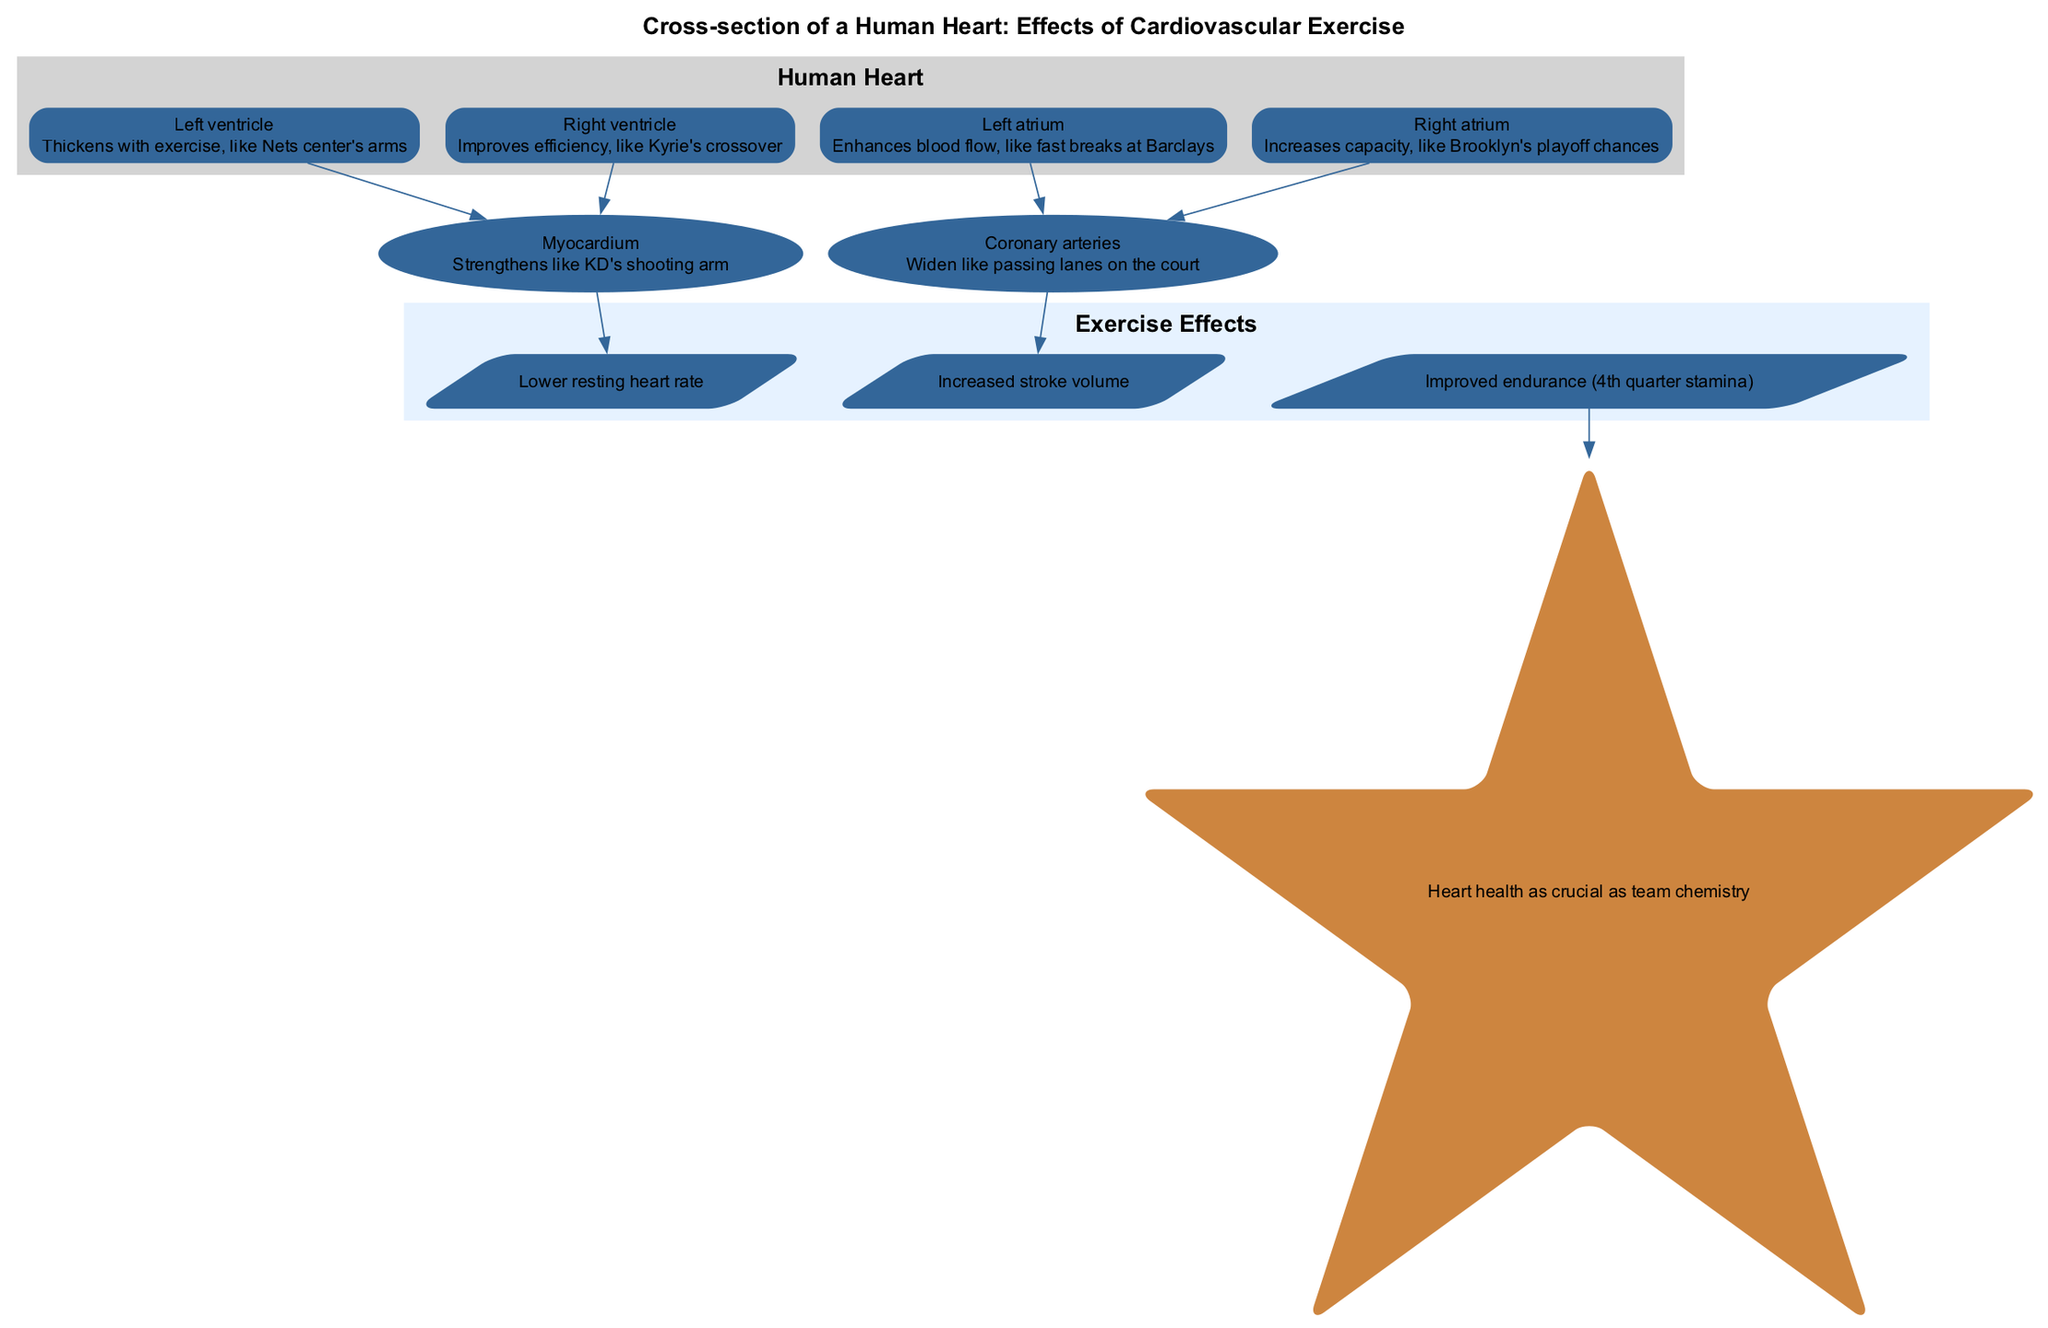What element thickens with exercise? The diagram indicates that the "Left ventricle" thickens with exercise, as it is specifically mentioned in the description associated with this element.
Answer: Left ventricle Which element improves efficiency? The "Right ventricle" is described in the diagram as improving efficiency, indicating its enhanced performance due to cardiovascular exercise.
Answer: Right ventricle What does the left atrium enhance? The description for the "Left atrium" states that it enhances blood flow, which reflects its role in the heart's functionality as drawn in the diagram.
Answer: Blood flow How many main elements are highlighted? The diagram shows a total of four main elements (Left ventricle, Right ventricle, Left atrium, Right atrium), as indicated in the main elements section.
Answer: 4 What effect does cardiovascular exercise have on resting heart rate? The diagram lists the effect of cardiovascular exercise resulting in a "Lower resting heart rate," suggesting a fundamental change in how the heart functions post-exercise.
Answer: Lower resting heart rate What does the right atrium increase? According to the diagram, the "Right atrium" increases its capacity, which is highlighted in its description, indicating a positive adaptation from exercise.
Answer: Capacity What element strengthens like KD's shooting arm? The "Myocardium" is specified to strengthen like KD's shooting arm, indicating its increased mass and efficiency due to exercise as per the diagram.
Answer: Myocardium What is the relationship between coronary arteries and exercise effects? The coronary arteries are linked to one of the exercise effects, specifically the effect identified as "Improved endurance (4th quarter stamina)," demonstrating their importance in sustaining physical activity.
Answer: Improved endurance What is highlighted as crucial as team chemistry? The diagram emphasizes that "Heart health" is crucial as team chemistry, drawing a parallel between physical health and the success of a sports team, particularly relevant to a basketball context.
Answer: Heart health 